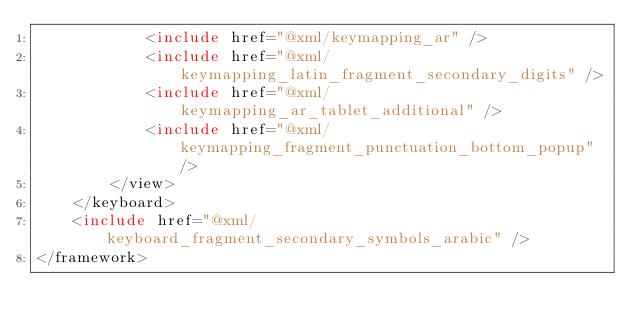Convert code to text. <code><loc_0><loc_0><loc_500><loc_500><_XML_>            <include href="@xml/keymapping_ar" />
            <include href="@xml/keymapping_latin_fragment_secondary_digits" />
            <include href="@xml/keymapping_ar_tablet_additional" />
            <include href="@xml/keymapping_fragment_punctuation_bottom_popup" />
        </view>
    </keyboard>
    <include href="@xml/keyboard_fragment_secondary_symbols_arabic" />
</framework></code> 